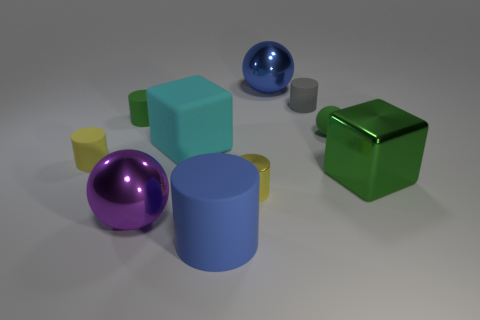How many objects seem to have a shiny surface, and can you describe them? In the image, there are two objects that have a notably shiny surface. One is a metallic cube with a reflective green surface, and the other is a metallic cylinder with a grayish-silver reflective finish. Both of them catch the light and stand out from the other objects due to their lustrous appearances. 